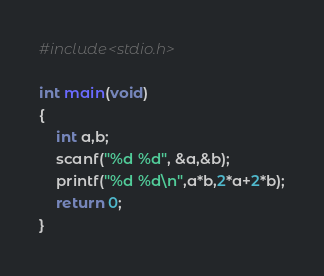<code> <loc_0><loc_0><loc_500><loc_500><_C_>#include<stdio.h>
 
int main(void)
{
    int a,b;
    scanf("%d %d", &a,&b);
    printf("%d %d\n",a*b,2*a+2*b);
    return 0;
}
</code> 